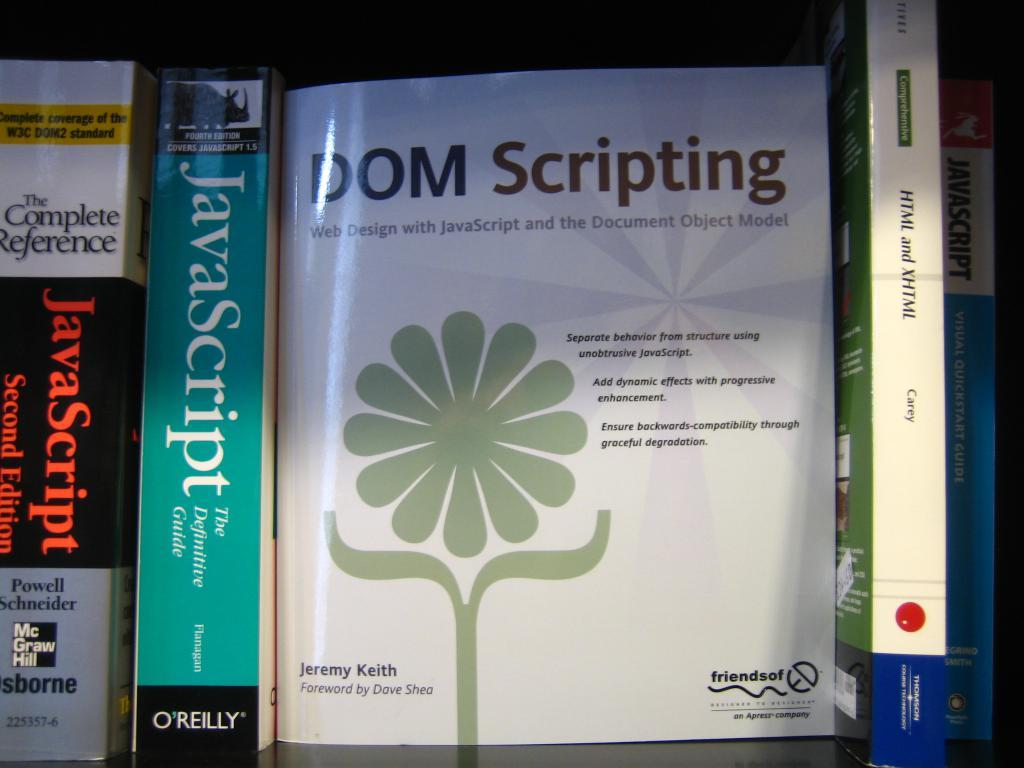<image>
Present a compact description of the photo's key features. Front cover of a book called "DOM Scripting". 